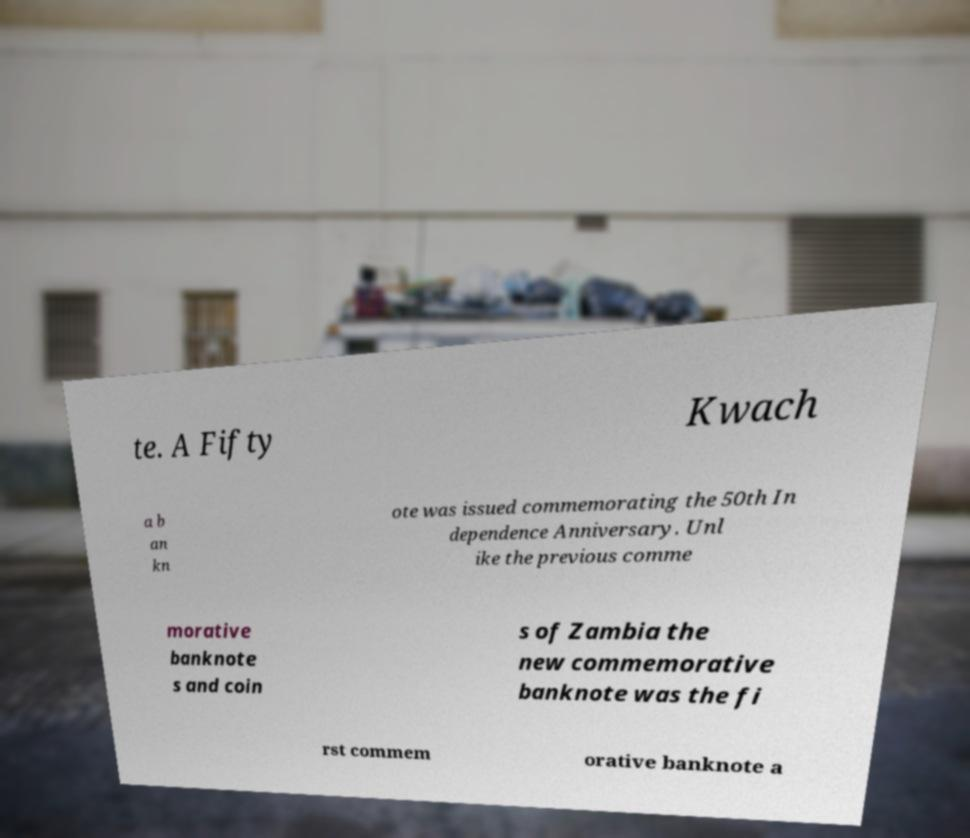Can you accurately transcribe the text from the provided image for me? te. A Fifty Kwach a b an kn ote was issued commemorating the 50th In dependence Anniversary. Unl ike the previous comme morative banknote s and coin s of Zambia the new commemorative banknote was the fi rst commem orative banknote a 